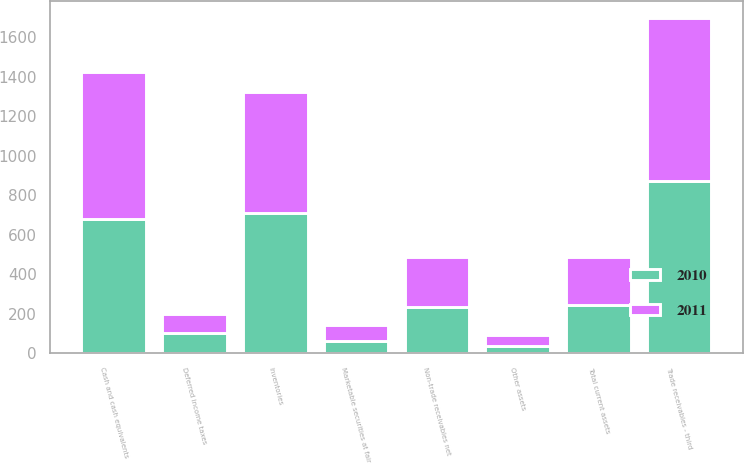Convert chart. <chart><loc_0><loc_0><loc_500><loc_500><stacked_bar_chart><ecel><fcel>Cash and cash equivalents<fcel>Trade receivables - third<fcel>Non-trade receivables net<fcel>Inventories<fcel>Deferred income taxes<fcel>Marketable securities at fair<fcel>Other assets<fcel>Total current assets<nl><fcel>2010<fcel>682<fcel>871<fcel>235<fcel>712<fcel>104<fcel>64<fcel>35<fcel>244<nl><fcel>2011<fcel>740<fcel>827<fcel>253<fcel>610<fcel>92<fcel>78<fcel>59<fcel>244<nl></chart> 